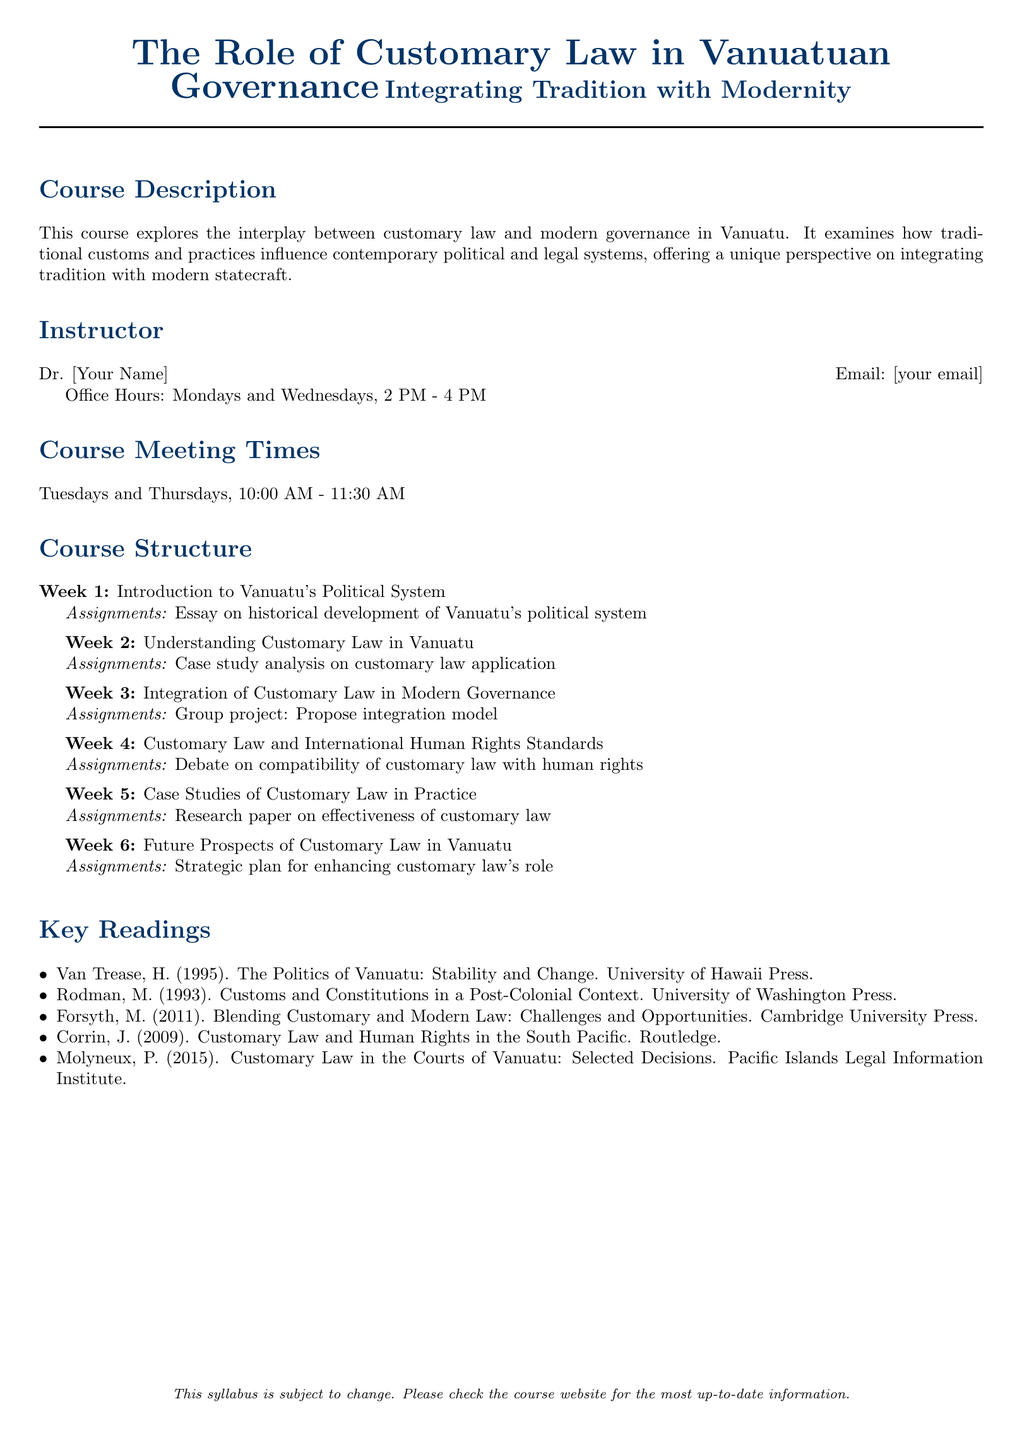What is the course title? The course title is prominently displayed at the beginning of the document.
Answer: The Role of Customary Law in Vanuatuan Governance Who is the instructor? The instructor's name is listed in the course structure section.
Answer: Dr. [Your Name] What day and time does the course meet? The meeting times are specified in the course structure section.
Answer: Tuesdays and Thursdays, 10:00 AM - 11:30 AM How many weeks does the course last? The number of weeks is indicated by the entries in the course structure section.
Answer: 6 What type of assignment is given in Week 1? Each week includes specific assignments, which are noted next to the week number.
Answer: Essay on historical development of Vanuatu's political system Which reading is focused on human rights in the South Pacific? The key readings section lists various readings, including one related to human rights.
Answer: Corrin, J. (2009). Customary Law and Human Rights in the South Pacific What is one of the topics covered in Week 4? The topic for Week 4 is specified in the course structure section.
Answer: Customary Law and International Human Rights Standards What is the focus of Week 6? Each week's entry provides a focus or topic for discussion or study.
Answer: Future Prospects of Customary Law in Vanuatu 